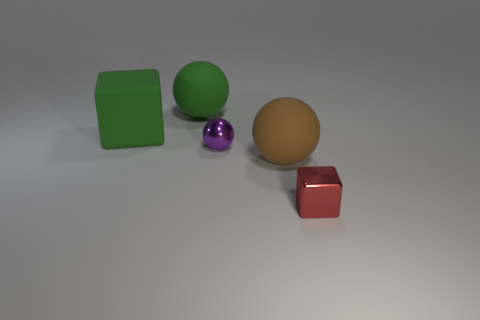How many objects are either big spheres that are behind the small purple sphere or small brown cylinders?
Ensure brevity in your answer.  1. Are there any big green rubber things of the same shape as the purple metallic thing?
Provide a short and direct response. Yes. Are there the same number of small red objects that are left of the big green sphere and large green matte cubes?
Keep it short and to the point. No. There is a object that is the same color as the big rubber block; what is its shape?
Your response must be concise. Sphere. What number of metal balls are the same size as the green cube?
Offer a terse response. 0. What number of rubber objects are to the left of the brown matte ball?
Offer a very short reply. 2. What material is the cube to the left of the ball behind the big green block?
Offer a very short reply. Rubber. Are there any other tiny blocks that have the same color as the small shiny block?
Offer a very short reply. No. What size is the purple object that is made of the same material as the red block?
Make the answer very short. Small. Are there any other things of the same color as the large rubber block?
Keep it short and to the point. Yes. 